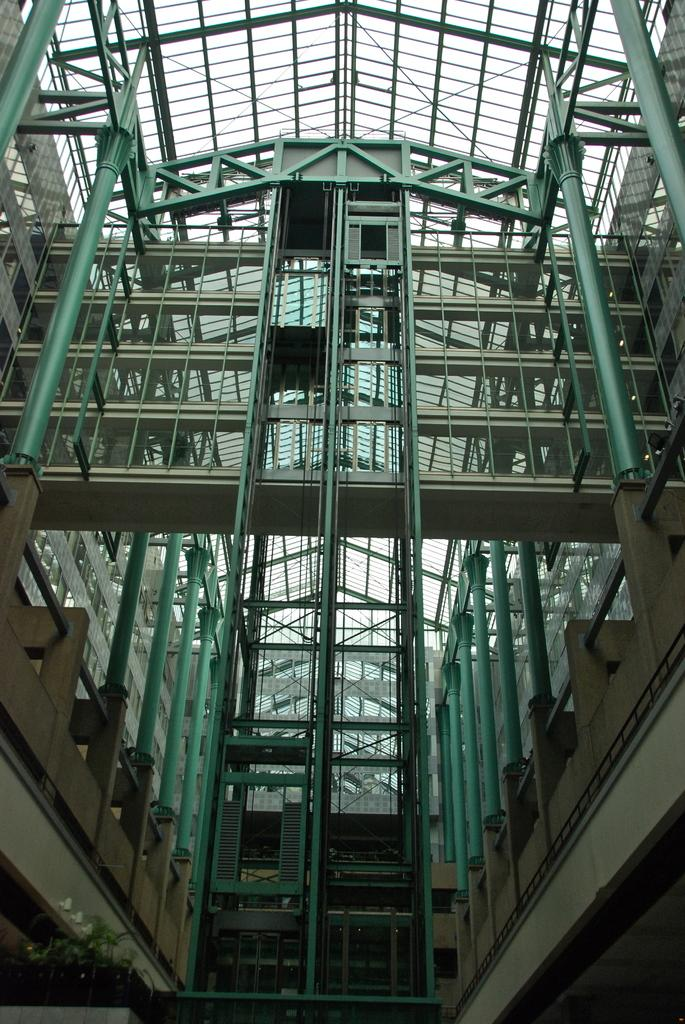Where is the location of the image? The image is inside a building. What architectural features can be seen in the image? There are pillars in the image. What part of the building is visible in the image? The rooftop is visible in the image. What type of vegetation is present in the image? There are plants in the image. What type of seat can be seen in the image? There is no seat present in the image. Can you tell me how many pigs are visible in the image? There are no pigs present in the image. 